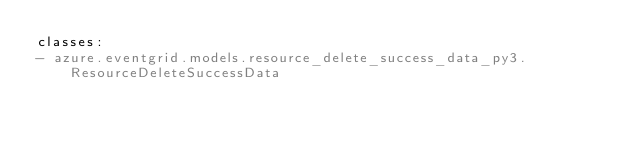Convert code to text. <code><loc_0><loc_0><loc_500><loc_500><_YAML_>classes:
- azure.eventgrid.models.resource_delete_success_data_py3.ResourceDeleteSuccessData
</code> 